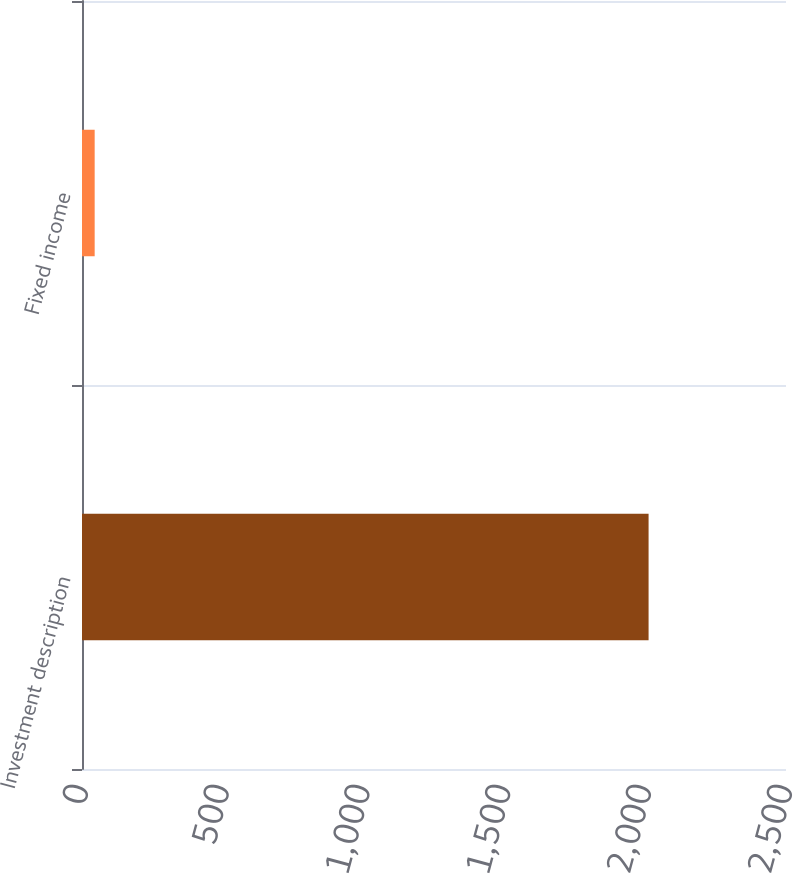Convert chart to OTSL. <chart><loc_0><loc_0><loc_500><loc_500><bar_chart><fcel>Investment description<fcel>Fixed income<nl><fcel>2012<fcel>45<nl></chart> 